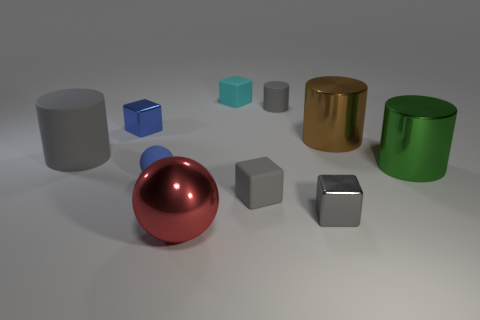Does the tiny metallic thing that is on the right side of the gray matte cube have the same color as the tiny cylinder?
Make the answer very short. Yes. There is a small shiny thing that is the same color as the matte ball; what shape is it?
Provide a succinct answer. Cube. Is the material of the gray cylinder right of the gray matte cube the same as the large object that is left of the small blue shiny block?
Your answer should be very brief. Yes. What is the color of the big matte cylinder?
Offer a very short reply. Gray. What number of blue metallic objects have the same shape as the tiny cyan rubber thing?
Give a very brief answer. 1. What color is the matte cylinder that is the same size as the blue rubber thing?
Offer a very short reply. Gray. Are there any big purple matte blocks?
Provide a short and direct response. No. The blue metallic thing that is to the right of the big gray cylinder has what shape?
Make the answer very short. Cube. How many things are in front of the tiny blue metal block and left of the red metallic sphere?
Offer a terse response. 2. Is there a gray cube made of the same material as the blue cube?
Keep it short and to the point. Yes. 